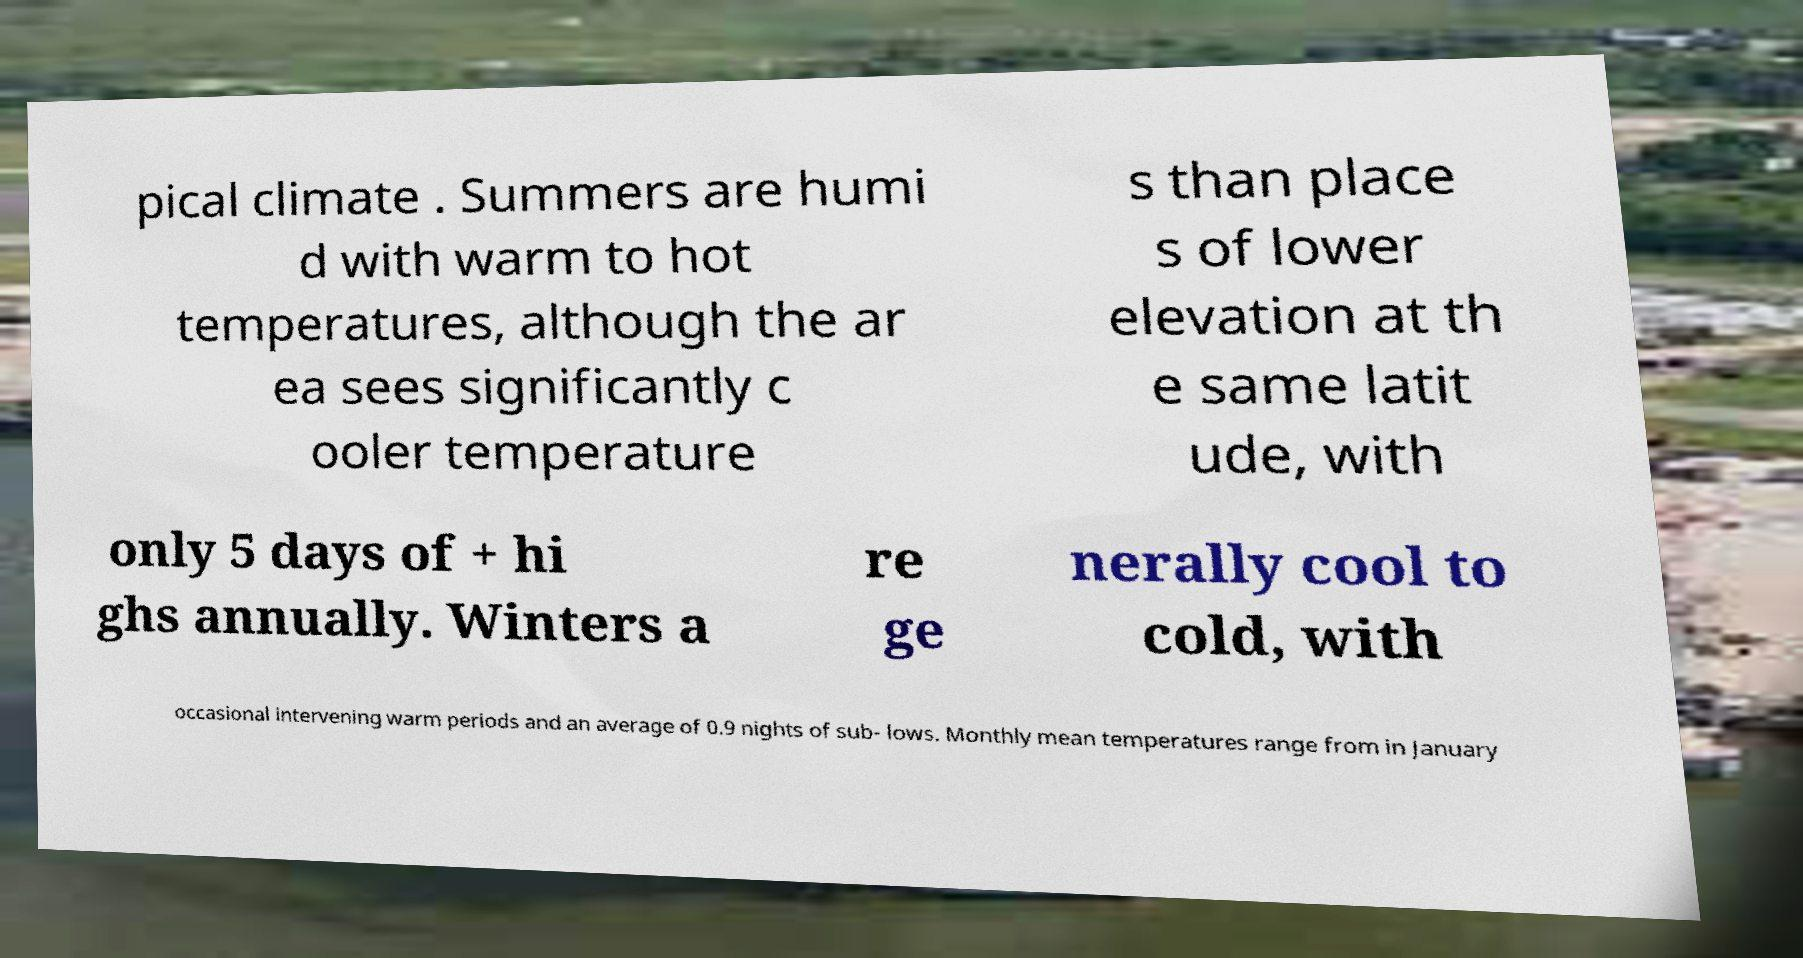Could you assist in decoding the text presented in this image and type it out clearly? pical climate . Summers are humi d with warm to hot temperatures, although the ar ea sees significantly c ooler temperature s than place s of lower elevation at th e same latit ude, with only 5 days of + hi ghs annually. Winters a re ge nerally cool to cold, with occasional intervening warm periods and an average of 0.9 nights of sub- lows. Monthly mean temperatures range from in January 